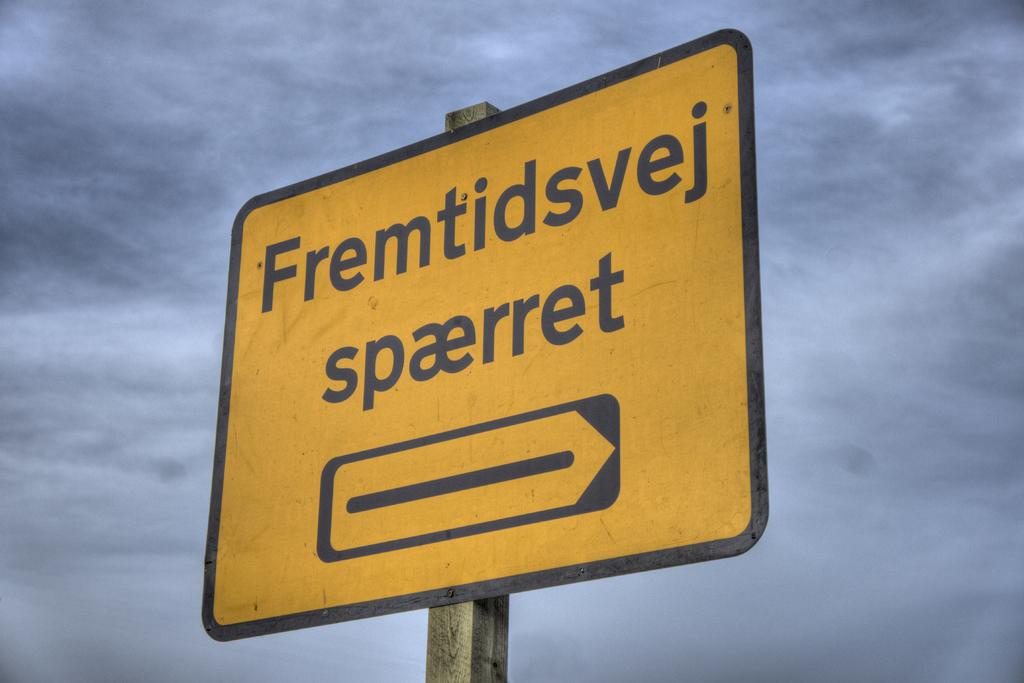What is the first word printed at the top of this road sign? it is in danish you do not need to translate it, just retype the word as you see it?
Give a very brief answer. Fremtidsvej. What is the bottom word on this sign?  it is in danish and you do not need to translate it.  just type it?
Keep it short and to the point. Spaerret. 